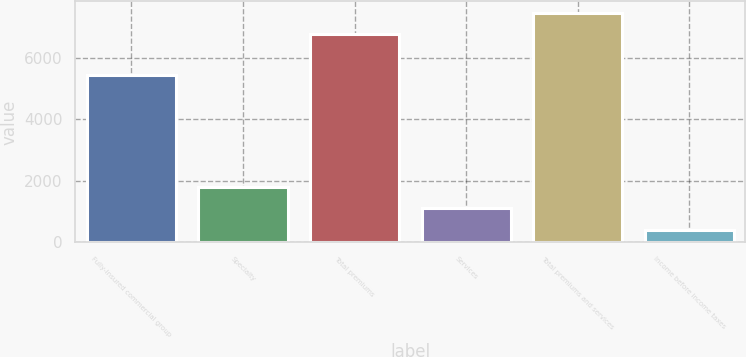Convert chart to OTSL. <chart><loc_0><loc_0><loc_500><loc_500><bar_chart><fcel>Fully-insured commercial group<fcel>Specialty<fcel>Total premiums<fcel>Services<fcel>Total premiums and services<fcel>Income before income taxes<nl><fcel>5462<fcel>1809.2<fcel>6772<fcel>1110.6<fcel>7470.6<fcel>412<nl></chart> 